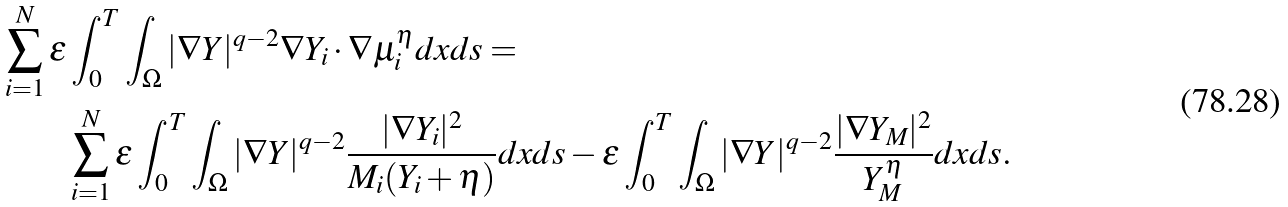<formula> <loc_0><loc_0><loc_500><loc_500>\sum ^ { N } _ { i = 1 } \varepsilon & \int _ { 0 } ^ { T } \int _ { \Omega } | \nabla Y | ^ { q - 2 } \nabla Y _ { i } \cdot \nabla \mu ^ { \eta } _ { i } d x d s = \\ & \sum ^ { N } _ { i = 1 } \varepsilon \int _ { 0 } ^ { T } \int _ { \Omega } | \nabla Y | ^ { q - 2 } \frac { | \nabla Y _ { i } | ^ { 2 } } { M _ { i } ( Y _ { i } + \eta ) } d x d s - \varepsilon \int _ { 0 } ^ { T } \int _ { \Omega } | \nabla Y | ^ { q - 2 } \frac { | \nabla Y _ { M } | ^ { 2 } } { Y ^ { \eta } _ { M } } d x d s .</formula> 